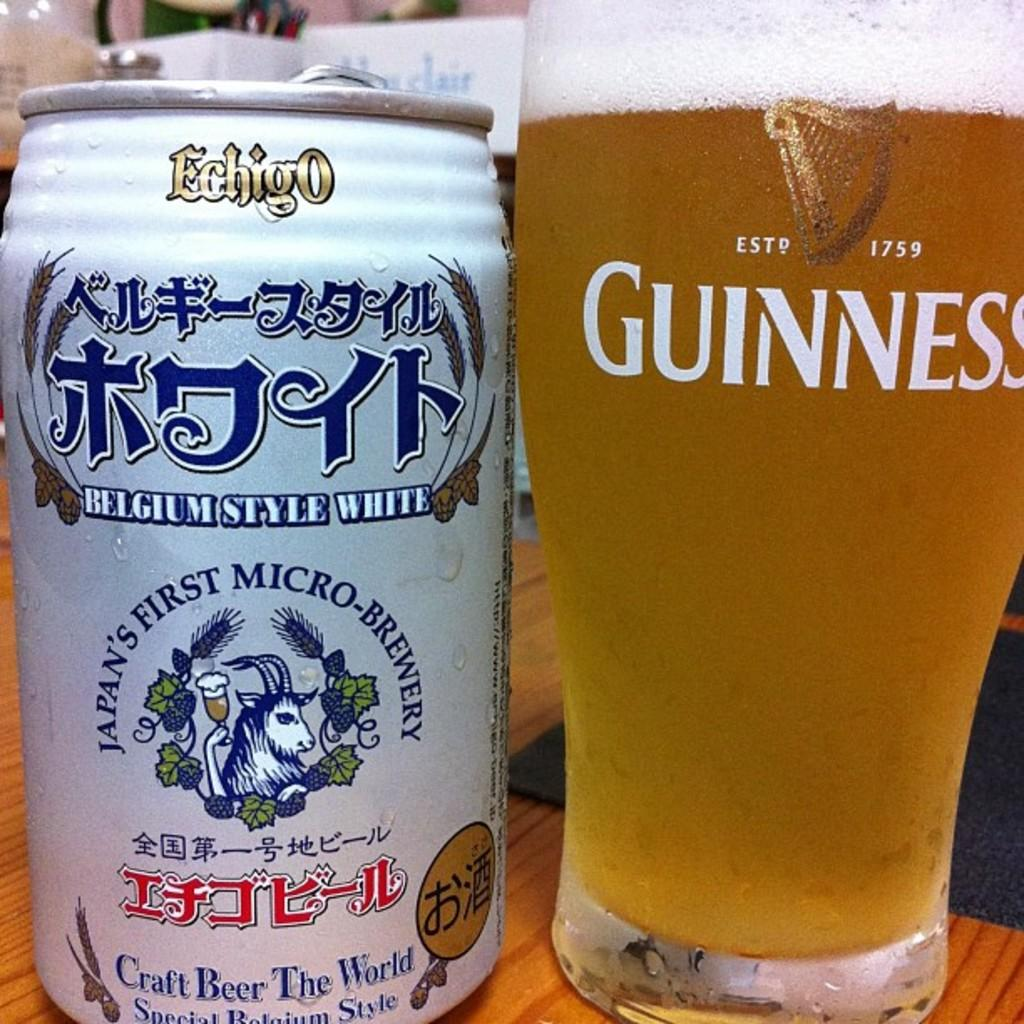<image>
Provide a brief description of the given image. A can of Beer which is from Japans first micro brewery stands next to a Guiness glass filled with that beer. 